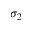<formula> <loc_0><loc_0><loc_500><loc_500>\sigma _ { 2 }</formula> 